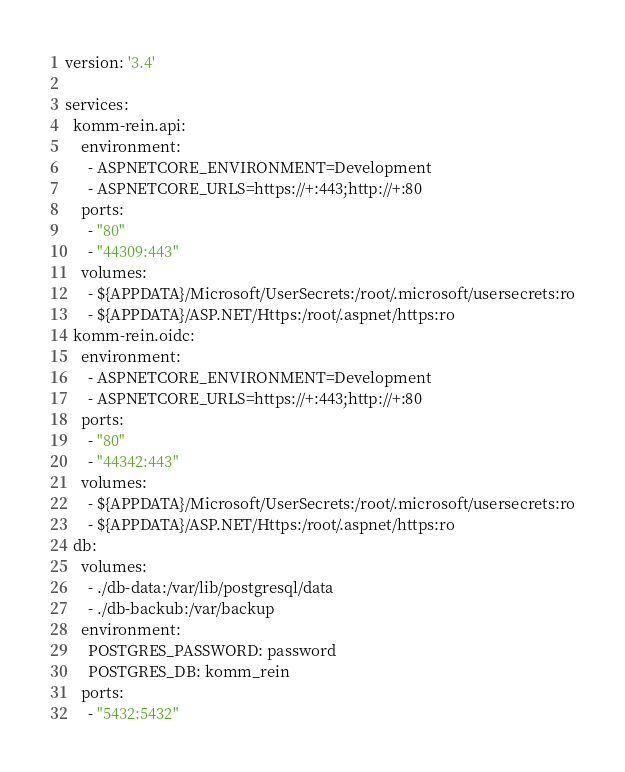Convert code to text. <code><loc_0><loc_0><loc_500><loc_500><_YAML_>version: '3.4'

services:
  komm-rein.api:
    environment:
      - ASPNETCORE_ENVIRONMENT=Development
      - ASPNETCORE_URLS=https://+:443;http://+:80
    ports:
      - "80"
      - "44309:443"
    volumes:
      - ${APPDATA}/Microsoft/UserSecrets:/root/.microsoft/usersecrets:ro
      - ${APPDATA}/ASP.NET/Https:/root/.aspnet/https:ro
  komm-rein.oidc:
    environment:
      - ASPNETCORE_ENVIRONMENT=Development
      - ASPNETCORE_URLS=https://+:443;http://+:80
    ports:
      - "80"
      - "44342:443"
    volumes:
      - ${APPDATA}/Microsoft/UserSecrets:/root/.microsoft/usersecrets:ro
      - ${APPDATA}/ASP.NET/Https:/root/.aspnet/https:ro
  db:
    volumes:
      - ./db-data:/var/lib/postgresql/data
      - ./db-backub:/var/backup
    environment:
      POSTGRES_PASSWORD: password
      POSTGRES_DB: komm_rein
    ports:
      - "5432:5432"</code> 